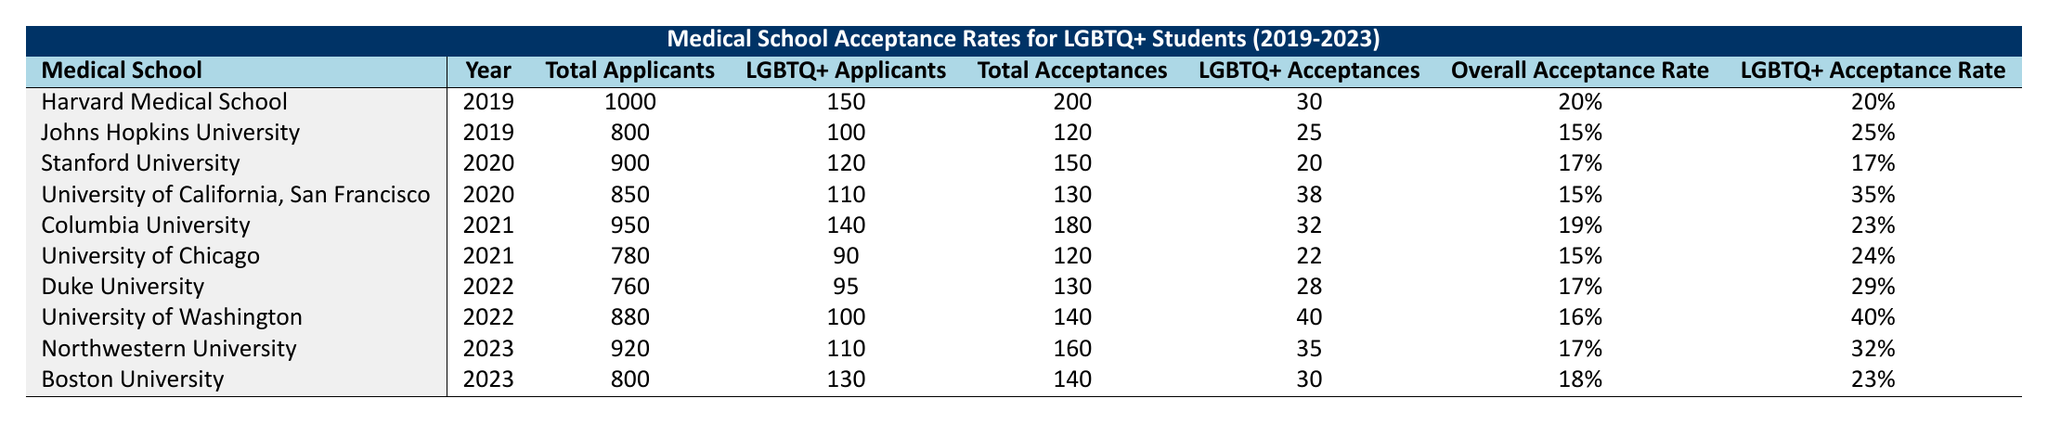What is the LGBTQ+ acceptance rate for Harvard Medical School in 2019? The table shows that Harvard Medical School had an LGBTQ+ acceptance rate of 20% in 2019.
Answer: 20% Which medical school had the highest LGBTQ+ acceptance rate in 2022? The University of Washington had the highest LGBTQ+ acceptance rate of 40% in 2022 according to the table.
Answer: University of Washington What was the total number of LGBTQ+ applicants across all medical schools in 2020? In 2020, the LGBTQ+ applicants were 120 from Stanford University and 110 from University of California, San Francisco. Summing these gives: 120 + 110 = 230.
Answer: 230 Did Johns Hopkins University have a higher overall acceptance rate than LGBTQ+ acceptance rate in 2019? The overall acceptance rate for Johns Hopkins University was 15%, while the LGBTQ+ acceptance rate was 25%. Since 15% is less than 25%, the statement is false.
Answer: No Which year saw an increase in the overall acceptance rate for LGBTQ+ students compared to the previous year? We look at the data for LGBTQ+ acceptance rates from 2019 to 2023. In 2021, the acceptance rate was 0.24 (University of Chicago) vs 0.25 (Johns Hopkins). However, 2023 has 0.32 (Northwestern University) which is higher than previous years, indicating an increase.
Answer: 2023 How many total acceptances were there at Columbia University in 2021? The table specifies that Columbia University had 180 total acceptances in 2021.
Answer: 180 Which medical school had the lowest LGBTQ+ acceptance rate in 2019? Analyzing the table for 2019, Harvard Medical School had a 20% LGBTQ+ acceptance rate, and Johns Hopkins University had 25%. Therefore, Harvard's rate of 20% is the lowest in that year.
Answer: Harvard Medical School What is the average LGBTQ+ acceptance rate for LGBTQ+ students across the five years? Adding the LGBTQ+ acceptance rates: (20% + 25% + 17% + 35% + 23% + 24% + 29% + 40% + 32% + 23%) =  24% and dividing by 10 gives an average of 24%.
Answer: 24% Which medical school had more total applicants in 2023: Northwestern University or Boston University? In 2023, Northwestern University had 920 total applicants, whereas Boston University had 800. Therefore, Northwestern University had more applicants.
Answer: Northwestern University Is it true that the acceptance rate for LGBTQ+ students has generally increased from 2020 to 2023? Comparing the rates from 2020, 2021, 2022, and 2023: 17%, 23%, 29%, and 32%, respectively, we see an increase each year from 17% to 32% indicating it is true.
Answer: Yes 